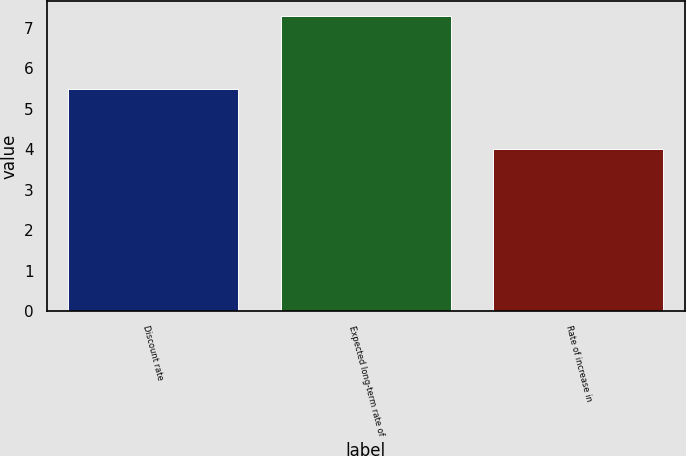Convert chart. <chart><loc_0><loc_0><loc_500><loc_500><bar_chart><fcel>Discount rate<fcel>Expected long-term rate of<fcel>Rate of increase in<nl><fcel>5.5<fcel>7.3<fcel>4<nl></chart> 